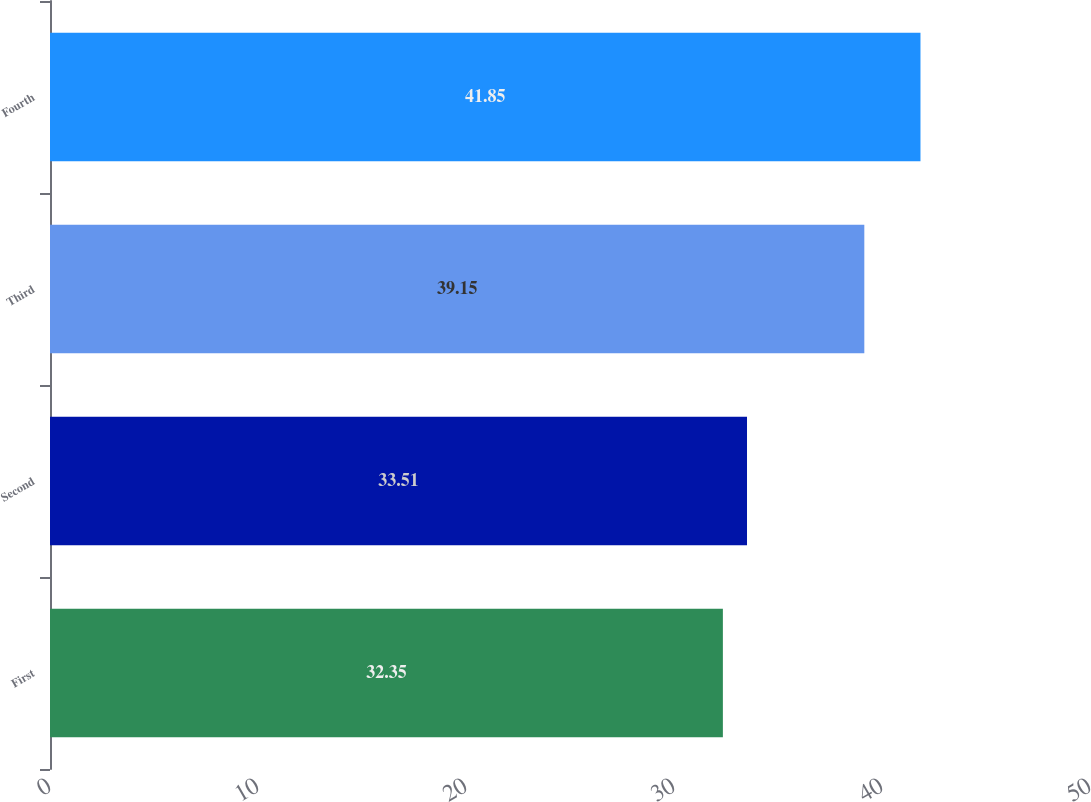<chart> <loc_0><loc_0><loc_500><loc_500><bar_chart><fcel>First<fcel>Second<fcel>Third<fcel>Fourth<nl><fcel>32.35<fcel>33.51<fcel>39.15<fcel>41.85<nl></chart> 